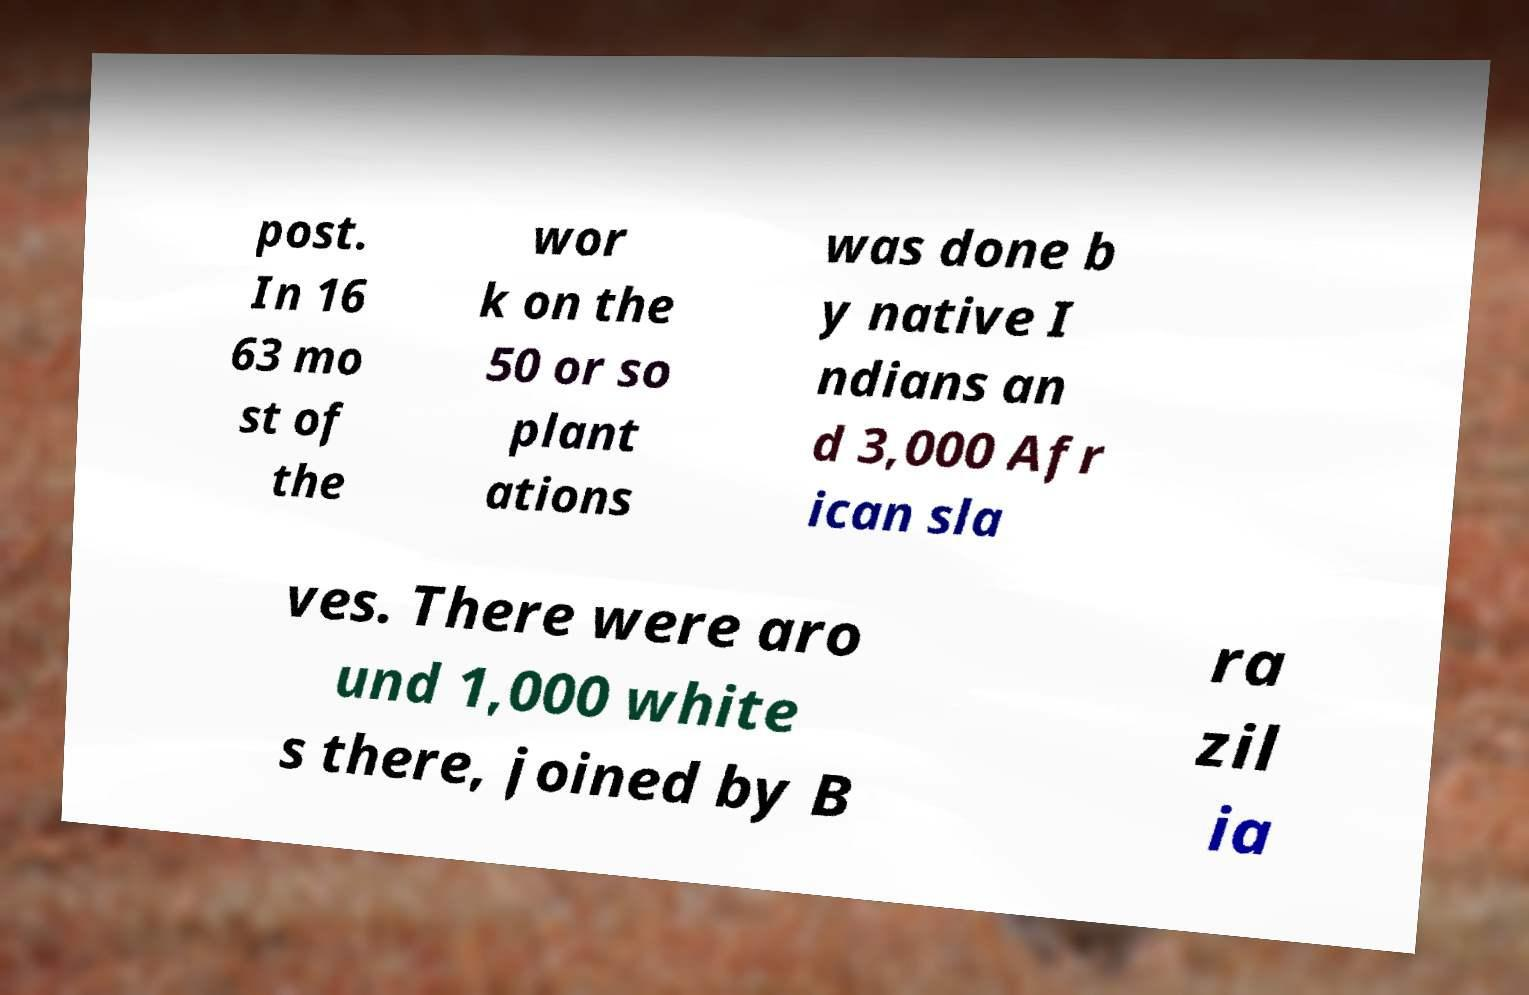Can you accurately transcribe the text from the provided image for me? post. In 16 63 mo st of the wor k on the 50 or so plant ations was done b y native I ndians an d 3,000 Afr ican sla ves. There were aro und 1,000 white s there, joined by B ra zil ia 